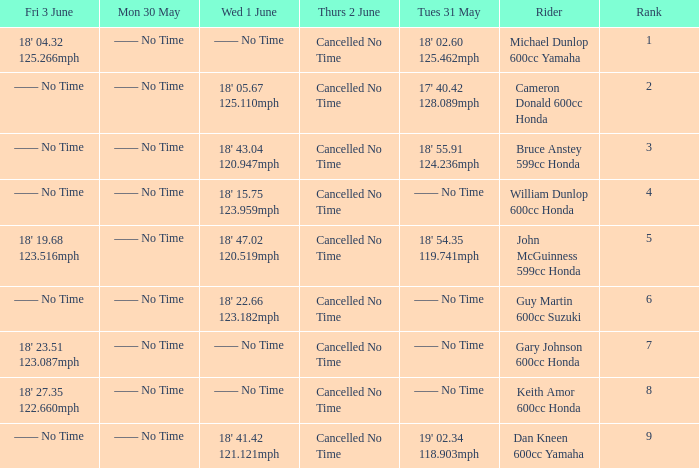What is the Fri 3 June time for the rider with a Weds 1 June time of 18' 22.66 123.182mph? —— No Time. 